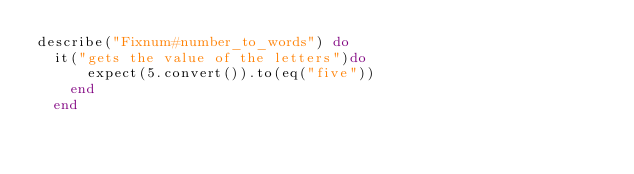Convert code to text. <code><loc_0><loc_0><loc_500><loc_500><_Ruby_>describe("Fixnum#number_to_words") do
  it("gets the value of the letters")do
      expect(5.convert()).to(eq("five"))
    end
  end
</code> 